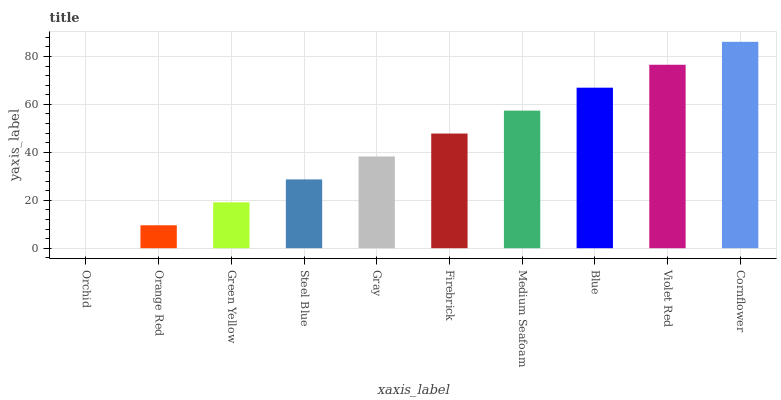Is Orchid the minimum?
Answer yes or no. Yes. Is Cornflower the maximum?
Answer yes or no. Yes. Is Orange Red the minimum?
Answer yes or no. No. Is Orange Red the maximum?
Answer yes or no. No. Is Orange Red greater than Orchid?
Answer yes or no. Yes. Is Orchid less than Orange Red?
Answer yes or no. Yes. Is Orchid greater than Orange Red?
Answer yes or no. No. Is Orange Red less than Orchid?
Answer yes or no. No. Is Firebrick the high median?
Answer yes or no. Yes. Is Gray the low median?
Answer yes or no. Yes. Is Steel Blue the high median?
Answer yes or no. No. Is Orchid the low median?
Answer yes or no. No. 